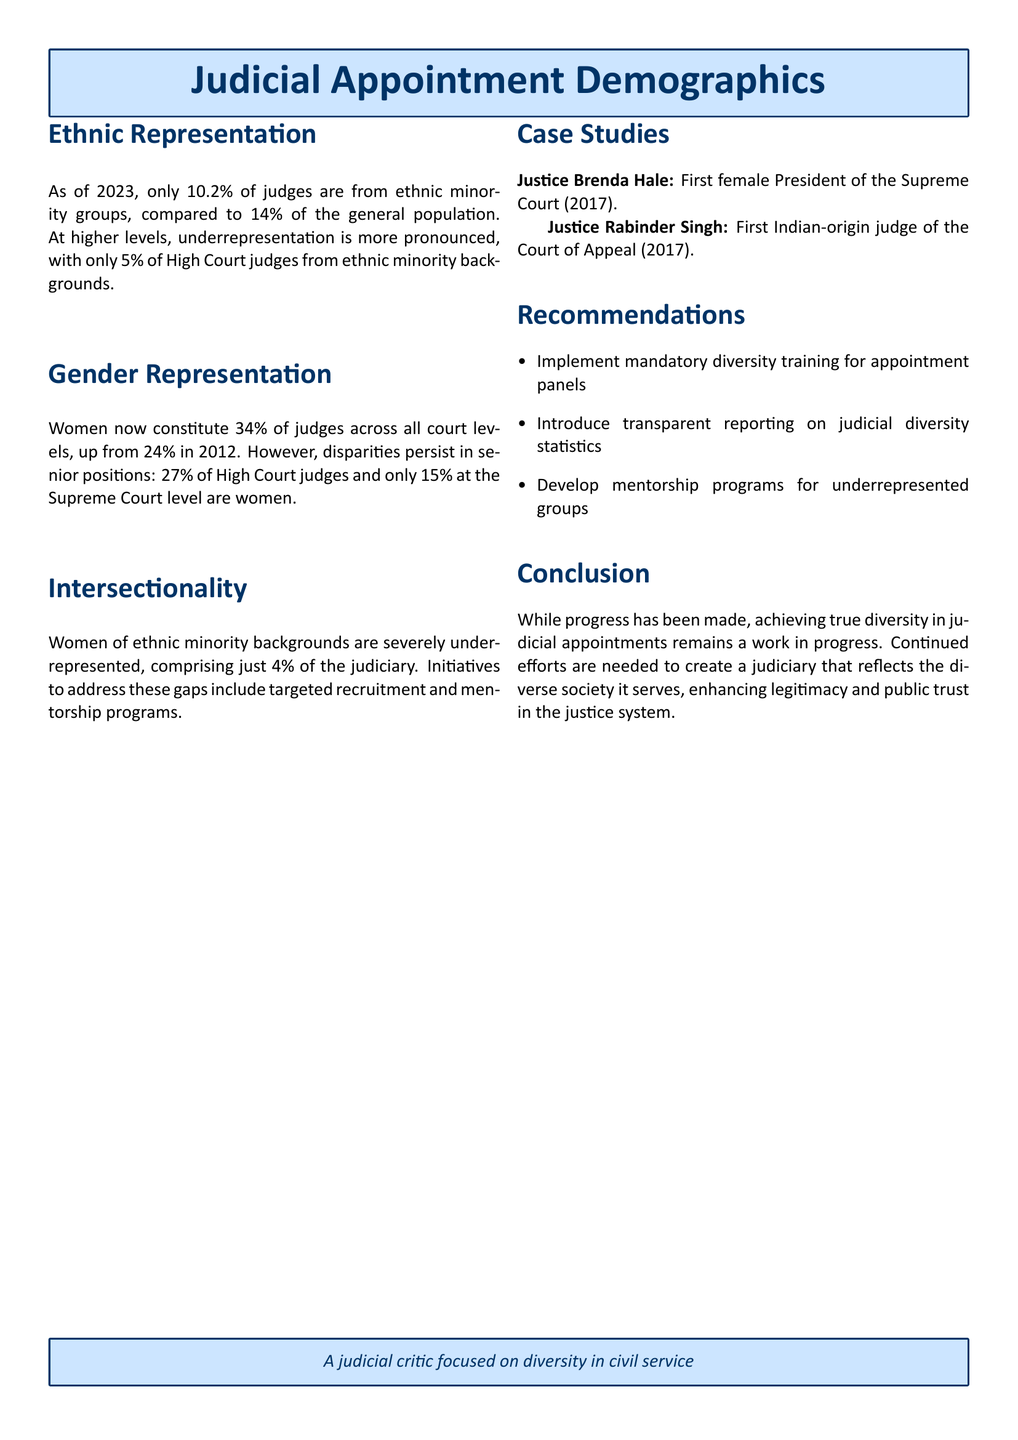what percentage of judges are from ethnic minority groups? The document states that as of 2023, only 10.2% of judges come from ethnic minority groups.
Answer: 10.2% what is the percentage of women judges in the Supreme Court? According to the document, only 15% of Supreme Court judges are women.
Answer: 15% what percentage of judges are women across all court levels? The document indicates that women constitute 34% of judges across all court levels.
Answer: 34% who was the first female President of the Supreme Court? The document mentions that Justice Brenda Hale was the first female President of the Supreme Court in 2017.
Answer: Justice Brenda Hale what percentage of High Court judges are from ethnic minority backgrounds? It states in the document that only 5% of High Court judges are from ethnic minority backgrounds.
Answer: 5% how many women of ethnic minority backgrounds are represented in the judiciary? The document notes that women of ethnic minority backgrounds comprise just 4% of the judiciary.
Answer: 4% what is one of the recommendations for improving judicial diversity? The document lists several recommendations, one of which is to implement mandatory diversity training for appointment panels.
Answer: Mandatory diversity training what year did Justice Rabinder Singh become the first Indian-origin judge of the Court of Appeal? The document indicates that Justice Rabinder Singh achieved this milestone in 2017.
Answer: 2017 what is stated as a necessary step to enhance public trust in the justice system? The document concludes that continued efforts are needed to enhance legitimacy and public trust in the justice system.
Answer: Continued efforts 